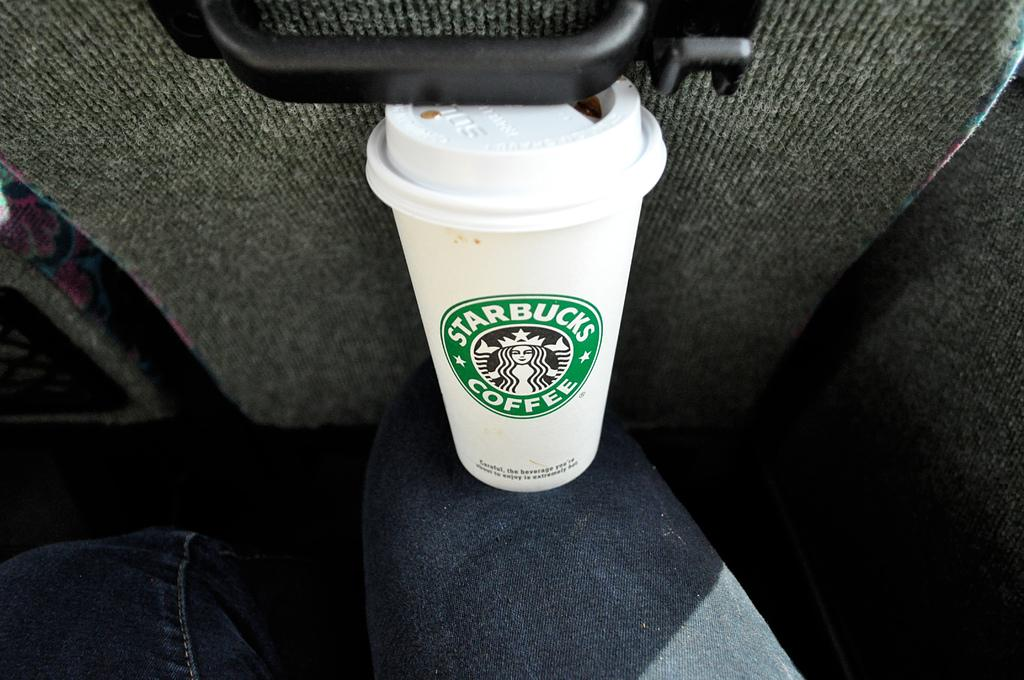What is present in the image? There is a person in the image. What is the person wearing? The person is wearing clothes. What object is on the person's leg? There is a coffee cup on the person's leg. What can be seen in front of the person? There is a seat in front of the person. What type of bear can be seen playing in the downtown area in the image? There is no bear or downtown area present in the image; it features a person with a coffee cup on their leg and a seat in front of them. 